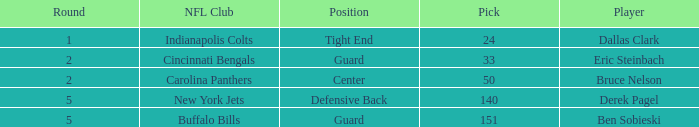What was the latest round that Derek Pagel was selected with a pick higher than 50? 5.0. 